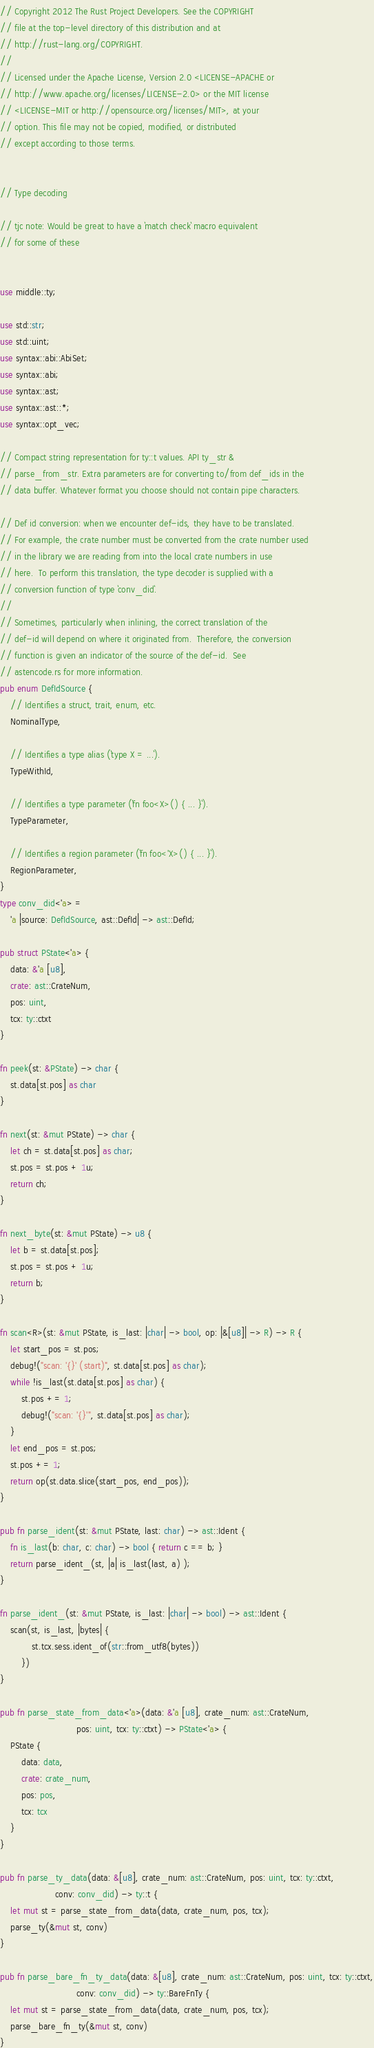<code> <loc_0><loc_0><loc_500><loc_500><_Rust_>// Copyright 2012 The Rust Project Developers. See the COPYRIGHT
// file at the top-level directory of this distribution and at
// http://rust-lang.org/COPYRIGHT.
//
// Licensed under the Apache License, Version 2.0 <LICENSE-APACHE or
// http://www.apache.org/licenses/LICENSE-2.0> or the MIT license
// <LICENSE-MIT or http://opensource.org/licenses/MIT>, at your
// option. This file may not be copied, modified, or distributed
// except according to those terms.


// Type decoding

// tjc note: Would be great to have a `match check` macro equivalent
// for some of these


use middle::ty;

use std::str;
use std::uint;
use syntax::abi::AbiSet;
use syntax::abi;
use syntax::ast;
use syntax::ast::*;
use syntax::opt_vec;

// Compact string representation for ty::t values. API ty_str &
// parse_from_str. Extra parameters are for converting to/from def_ids in the
// data buffer. Whatever format you choose should not contain pipe characters.

// Def id conversion: when we encounter def-ids, they have to be translated.
// For example, the crate number must be converted from the crate number used
// in the library we are reading from into the local crate numbers in use
// here.  To perform this translation, the type decoder is supplied with a
// conversion function of type `conv_did`.
//
// Sometimes, particularly when inlining, the correct translation of the
// def-id will depend on where it originated from.  Therefore, the conversion
// function is given an indicator of the source of the def-id.  See
// astencode.rs for more information.
pub enum DefIdSource {
    // Identifies a struct, trait, enum, etc.
    NominalType,

    // Identifies a type alias (`type X = ...`).
    TypeWithId,

    // Identifies a type parameter (`fn foo<X>() { ... }`).
    TypeParameter,

    // Identifies a region parameter (`fn foo<'X>() { ... }`).
    RegionParameter,
}
type conv_did<'a> =
    'a |source: DefIdSource, ast::DefId| -> ast::DefId;

pub struct PState<'a> {
    data: &'a [u8],
    crate: ast::CrateNum,
    pos: uint,
    tcx: ty::ctxt
}

fn peek(st: &PState) -> char {
    st.data[st.pos] as char
}

fn next(st: &mut PState) -> char {
    let ch = st.data[st.pos] as char;
    st.pos = st.pos + 1u;
    return ch;
}

fn next_byte(st: &mut PState) -> u8 {
    let b = st.data[st.pos];
    st.pos = st.pos + 1u;
    return b;
}

fn scan<R>(st: &mut PState, is_last: |char| -> bool, op: |&[u8]| -> R) -> R {
    let start_pos = st.pos;
    debug!("scan: '{}' (start)", st.data[st.pos] as char);
    while !is_last(st.data[st.pos] as char) {
        st.pos += 1;
        debug!("scan: '{}'", st.data[st.pos] as char);
    }
    let end_pos = st.pos;
    st.pos += 1;
    return op(st.data.slice(start_pos, end_pos));
}

pub fn parse_ident(st: &mut PState, last: char) -> ast::Ident {
    fn is_last(b: char, c: char) -> bool { return c == b; }
    return parse_ident_(st, |a| is_last(last, a) );
}

fn parse_ident_(st: &mut PState, is_last: |char| -> bool) -> ast::Ident {
    scan(st, is_last, |bytes| {
            st.tcx.sess.ident_of(str::from_utf8(bytes))
        })
}

pub fn parse_state_from_data<'a>(data: &'a [u8], crate_num: ast::CrateNum,
                             pos: uint, tcx: ty::ctxt) -> PState<'a> {
    PState {
        data: data,
        crate: crate_num,
        pos: pos,
        tcx: tcx
    }
}

pub fn parse_ty_data(data: &[u8], crate_num: ast::CrateNum, pos: uint, tcx: ty::ctxt,
                     conv: conv_did) -> ty::t {
    let mut st = parse_state_from_data(data, crate_num, pos, tcx);
    parse_ty(&mut st, conv)
}

pub fn parse_bare_fn_ty_data(data: &[u8], crate_num: ast::CrateNum, pos: uint, tcx: ty::ctxt,
                             conv: conv_did) -> ty::BareFnTy {
    let mut st = parse_state_from_data(data, crate_num, pos, tcx);
    parse_bare_fn_ty(&mut st, conv)
}
</code> 